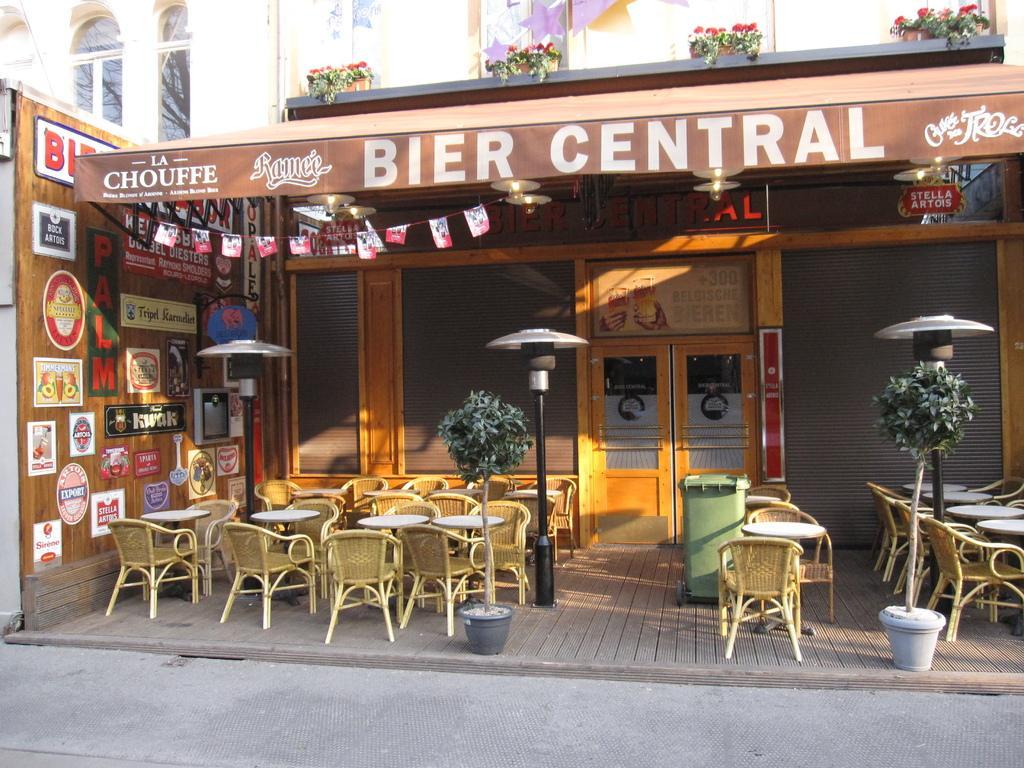Please provide a concise description of this image. This image is clicked outside. There are so many tables and chairs. There are plants in the middle. There are papers pasted on the left side. There are plants on the top. This looks like a store. There is a dustbin in the middle. 